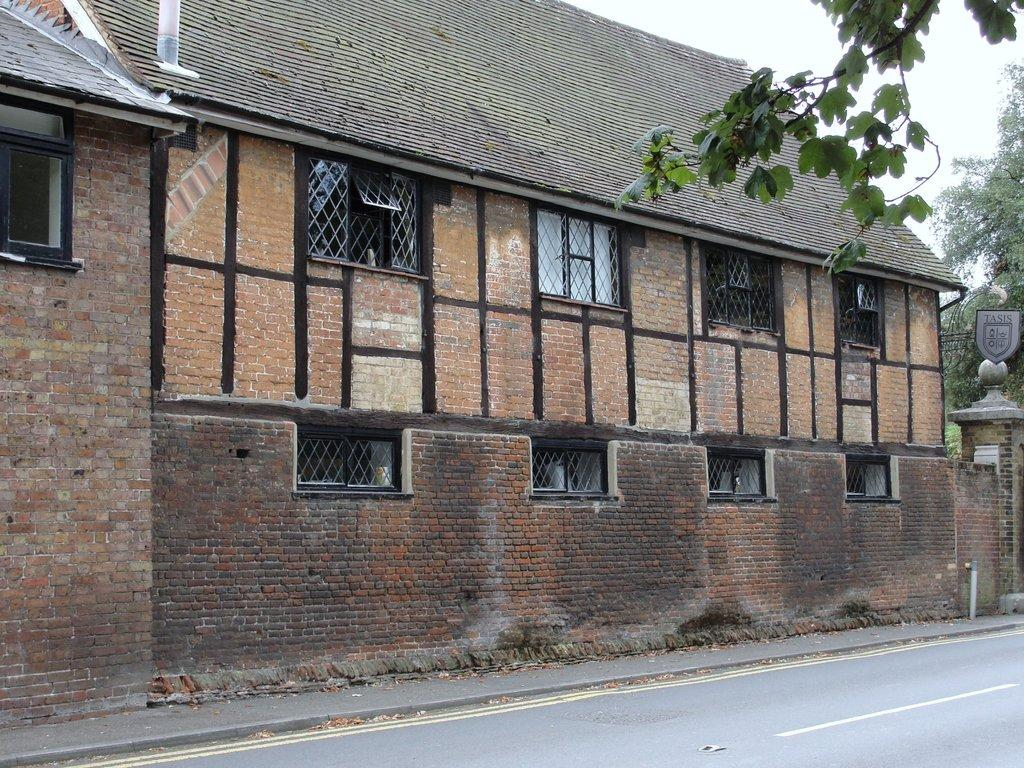What type of pathway is present in the image? There is a road in the image. What structure can be seen in the image? There is a building in the image. What type of natural elements are present in the image? There are trees in the image. What feature allows light to enter the building? There are windows in the image. What type of markings or symbols are visible in the image? There is text or writing visible in the image. Can you see any bananas on the road in the image? There are no bananas present on the road in the image. Are there any trains visible in the image? There are no trains visible in the image. 